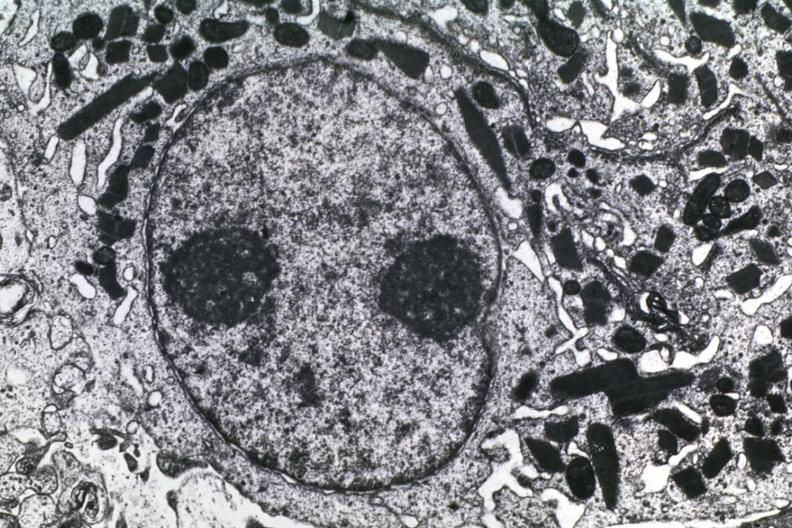what is present?
Answer the question using a single word or phrase. Brain 